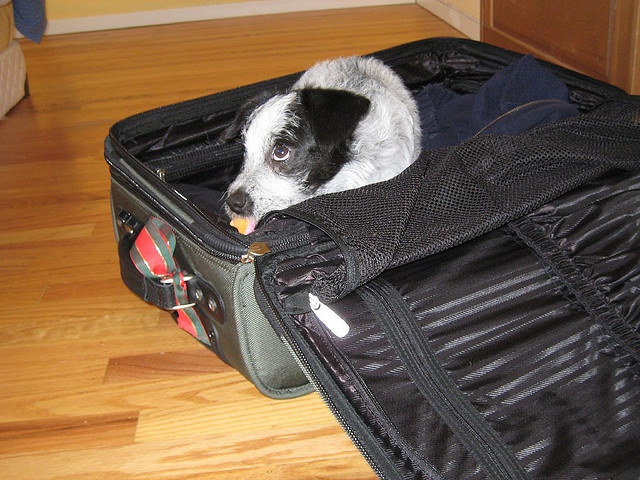Describe the objects in this image and their specific colors. I can see suitcase in gray, black, and darkgray tones and dog in gray, lightgray, black, and darkgray tones in this image. 